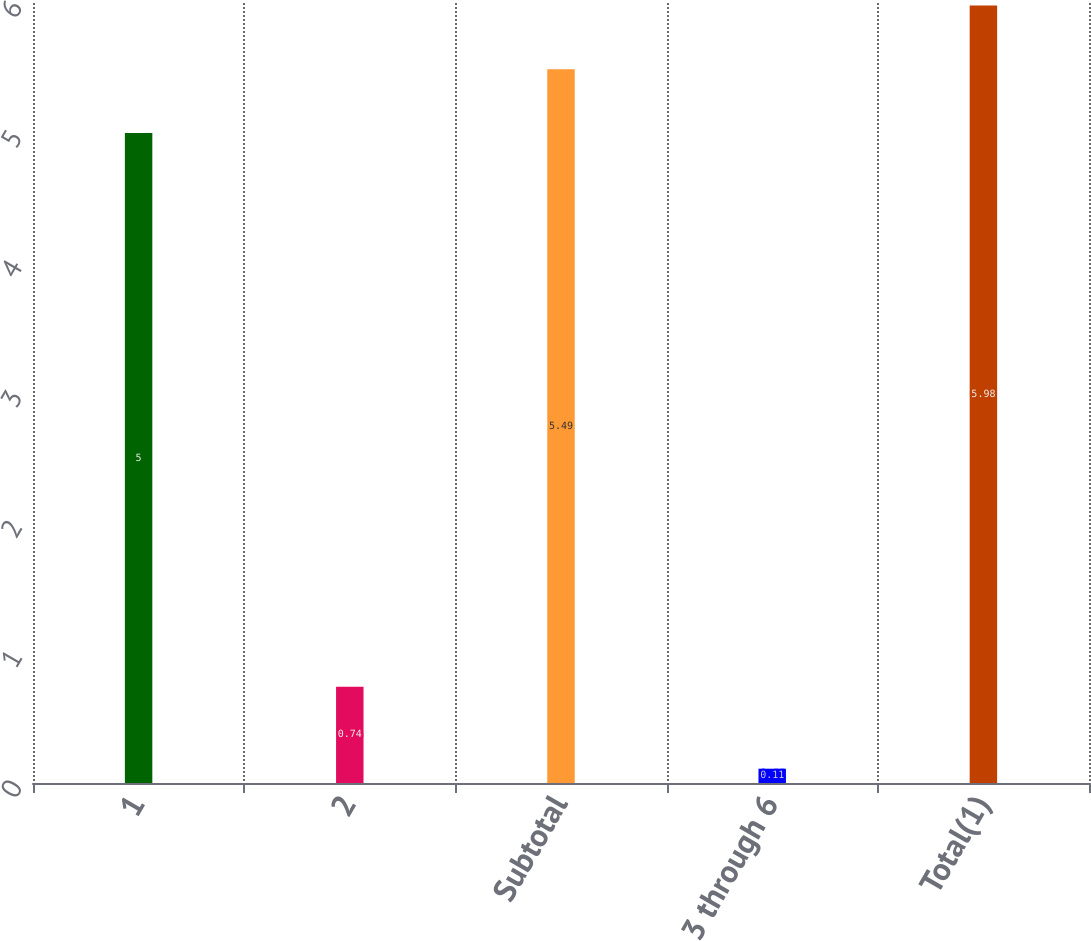Convert chart. <chart><loc_0><loc_0><loc_500><loc_500><bar_chart><fcel>1<fcel>2<fcel>Subtotal<fcel>3 through 6<fcel>Total(1)<nl><fcel>5<fcel>0.74<fcel>5.49<fcel>0.11<fcel>5.98<nl></chart> 